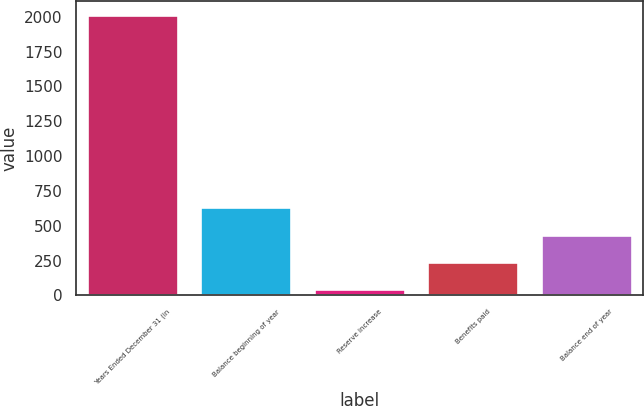<chart> <loc_0><loc_0><loc_500><loc_500><bar_chart><fcel>Years Ended December 31 (in<fcel>Balance beginning of year<fcel>Reserve increase<fcel>Benefits paid<fcel>Balance end of year<nl><fcel>2012<fcel>633.7<fcel>43<fcel>239.9<fcel>436.8<nl></chart> 